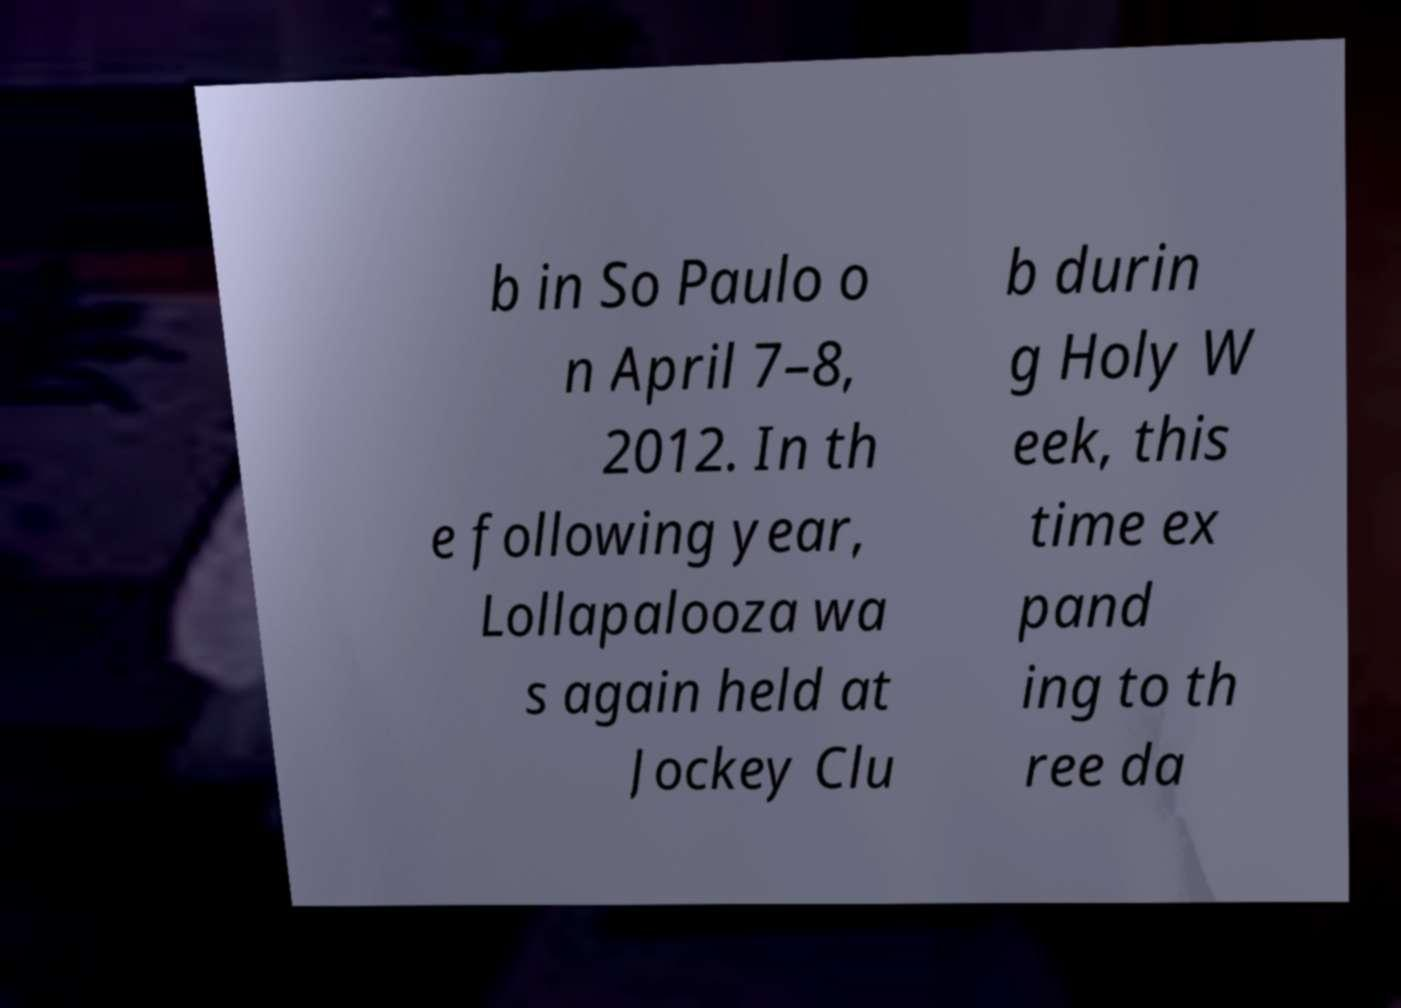What messages or text are displayed in this image? I need them in a readable, typed format. b in So Paulo o n April 7–8, 2012. In th e following year, Lollapalooza wa s again held at Jockey Clu b durin g Holy W eek, this time ex pand ing to th ree da 